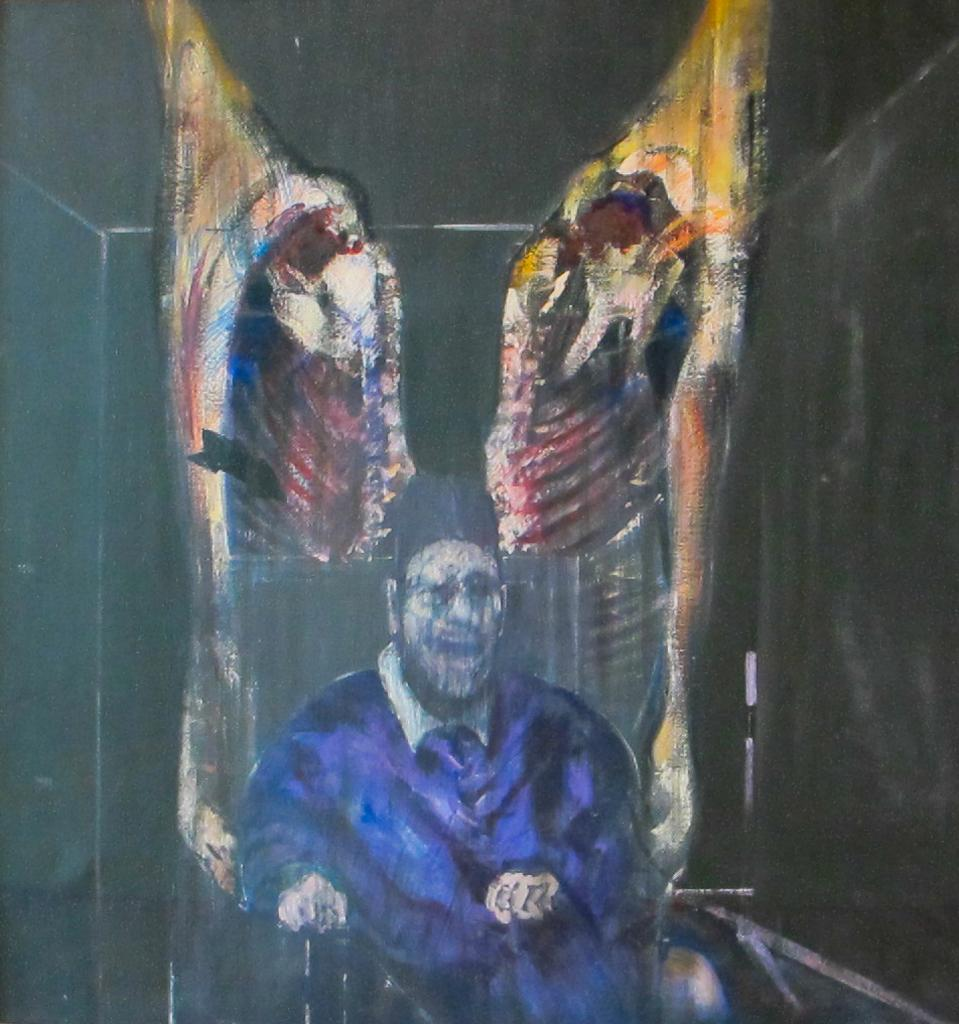What is the main subject of the image? There is a painting in the image. What is the painting depicting? The painting depicts a man. What is the man doing in the painting? The man is sitting on a chair in the painting. Can you see a tiger skate in the painting? No, there is no tiger or skating depicted in the painting; it features a man sitting on a chair. 